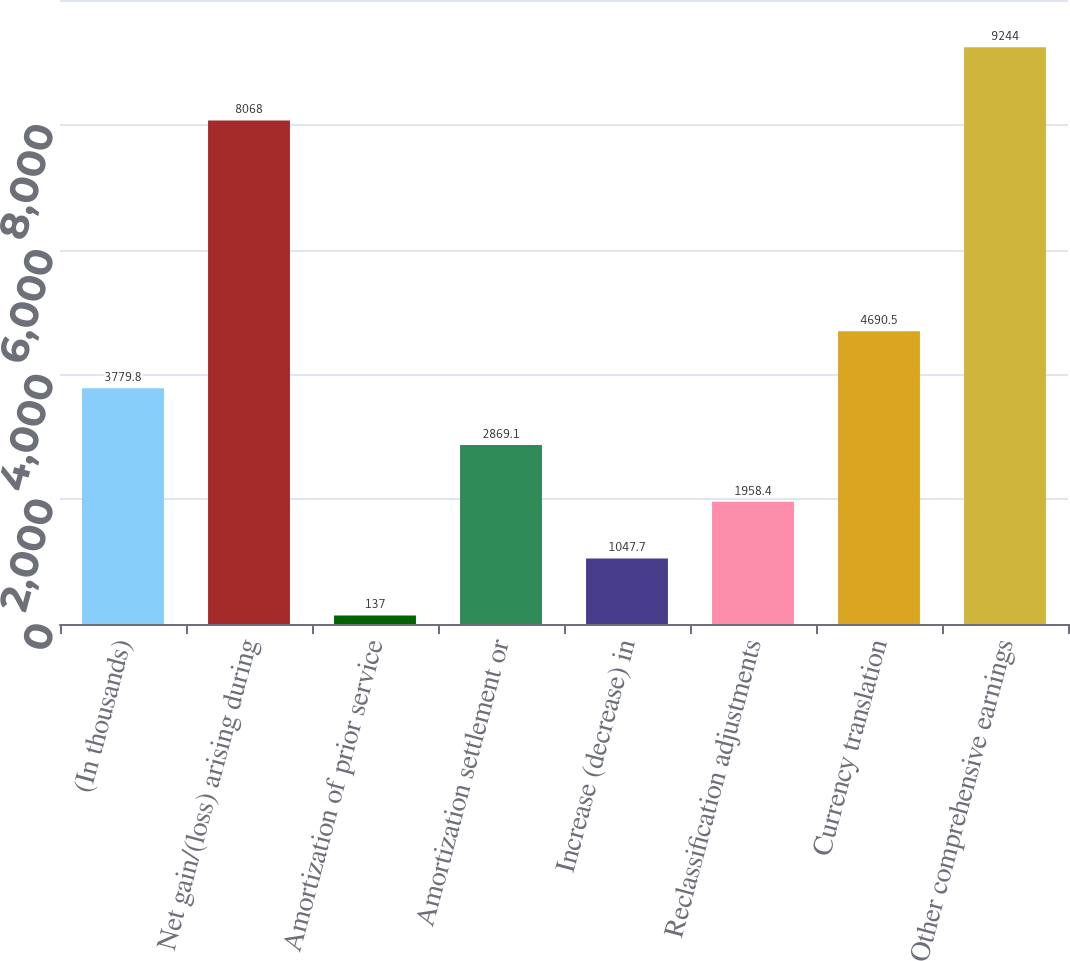Convert chart to OTSL. <chart><loc_0><loc_0><loc_500><loc_500><bar_chart><fcel>(In thousands)<fcel>Net gain/(loss) arising during<fcel>Amortization of prior service<fcel>Amortization settlement or<fcel>Increase (decrease) in<fcel>Reclassification adjustments<fcel>Currency translation<fcel>Other comprehensive earnings<nl><fcel>3779.8<fcel>8068<fcel>137<fcel>2869.1<fcel>1047.7<fcel>1958.4<fcel>4690.5<fcel>9244<nl></chart> 